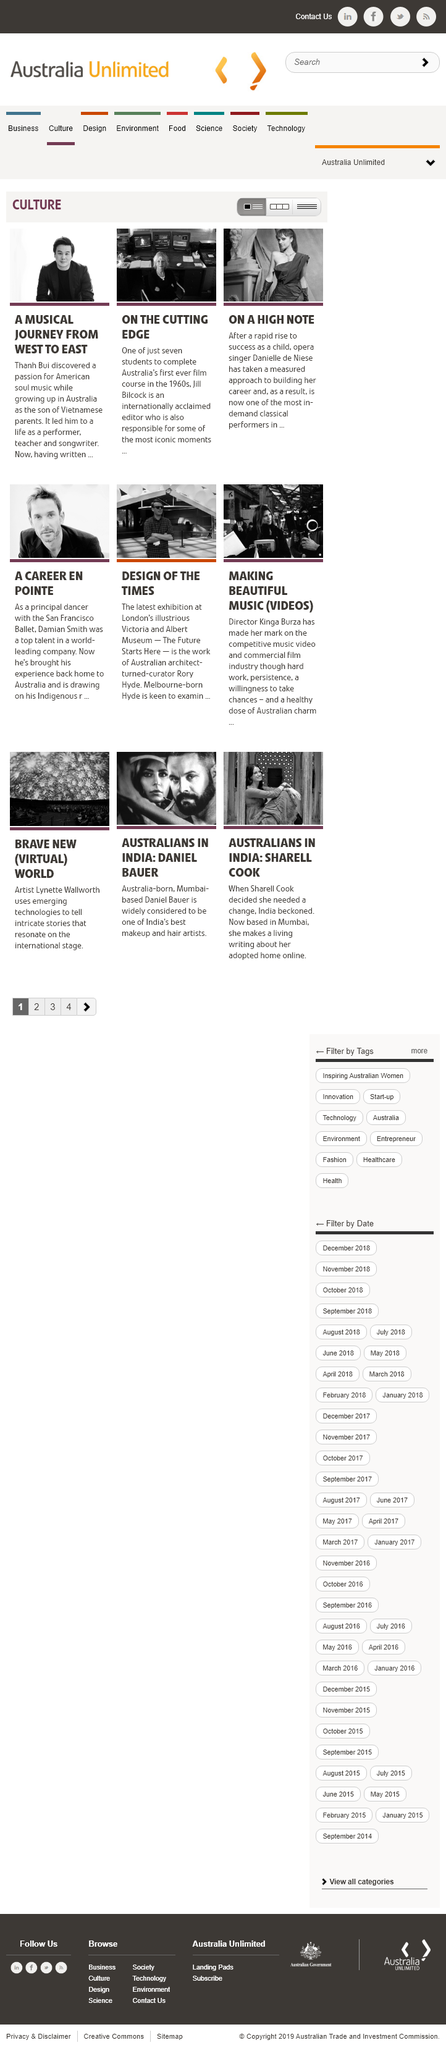Draw attention to some important aspects in this diagram. Thanh Bui had a passion for American soul music. The picture depicts a woman wearing a dress and gloves, who is identified as Danielle de Niese. The completion of Australia's first ever film course in the 1960s was achieved by 7 students. 